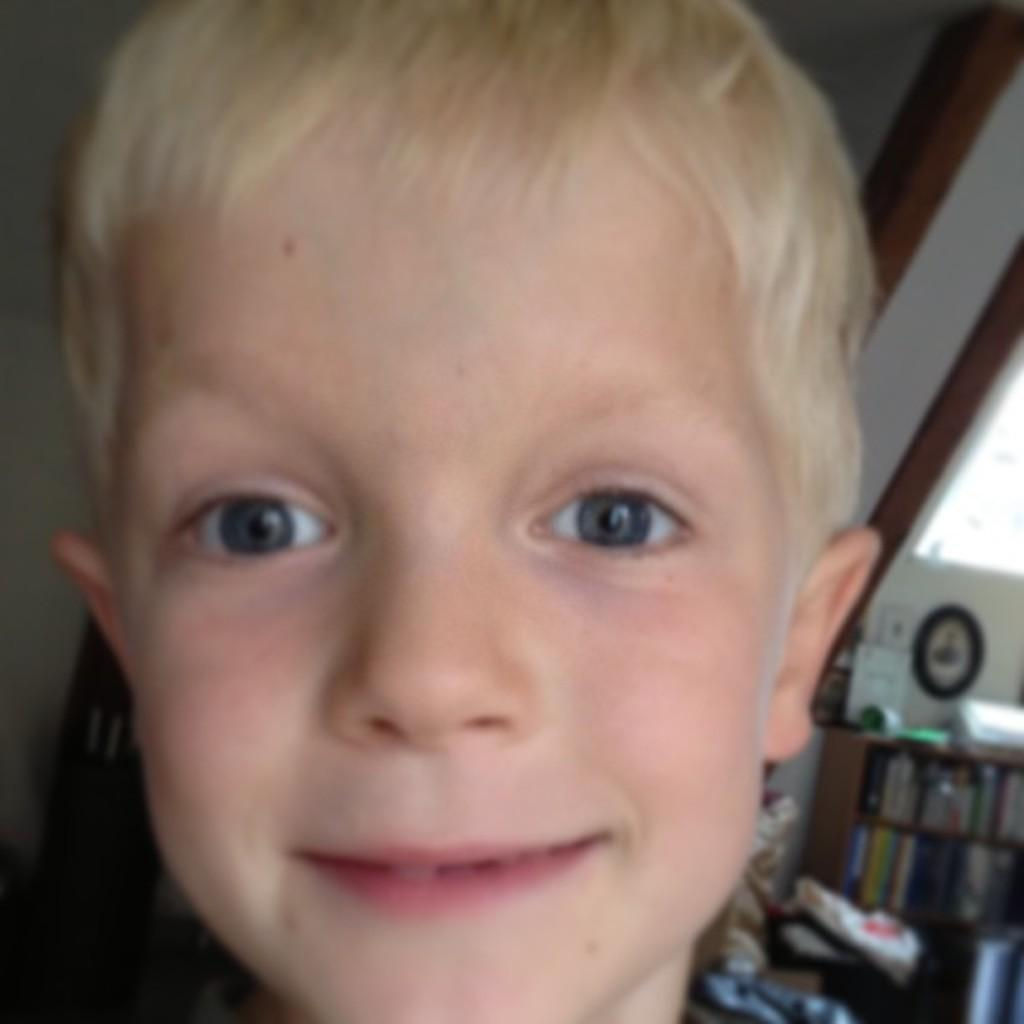Who or what is the main subject in the image? There is a person in the image. What can be seen in the background behind the person? There is a rack with books and some objects visible in the background. Can you describe the items on the rack in the background? The rack in the background contains books. What else is present in the background? Many papers are also present in the background. Is there a coach visible in the image? No, there is no coach present in the image. Can you see a bike in the background? No, there is no bike visible in the image. 